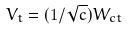Convert formula to latex. <formula><loc_0><loc_0><loc_500><loc_500>V _ { t } = ( 1 / \sqrt { c } ) W _ { c t }</formula> 